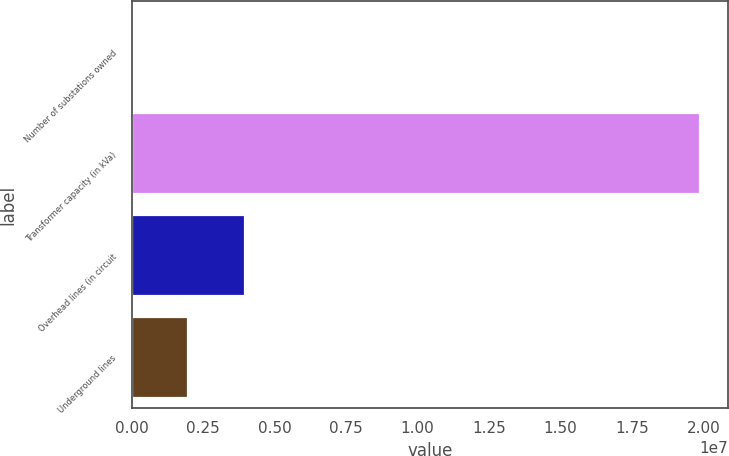Convert chart to OTSL. <chart><loc_0><loc_0><loc_500><loc_500><bar_chart><fcel>Number of substations owned<fcel>Transformer capacity (in kVa)<fcel>Overhead lines (in circuit<fcel>Underground lines<nl><fcel>182<fcel>1.9874e+07<fcel>3.97495e+06<fcel>1.98756e+06<nl></chart> 